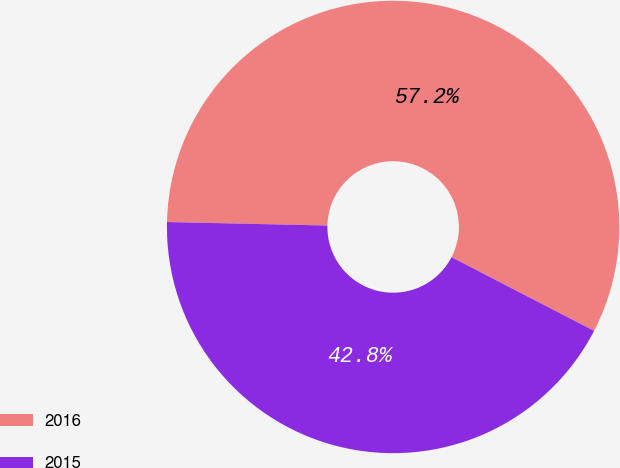<chart> <loc_0><loc_0><loc_500><loc_500><pie_chart><fcel>2016<fcel>2015<nl><fcel>57.25%<fcel>42.75%<nl></chart> 